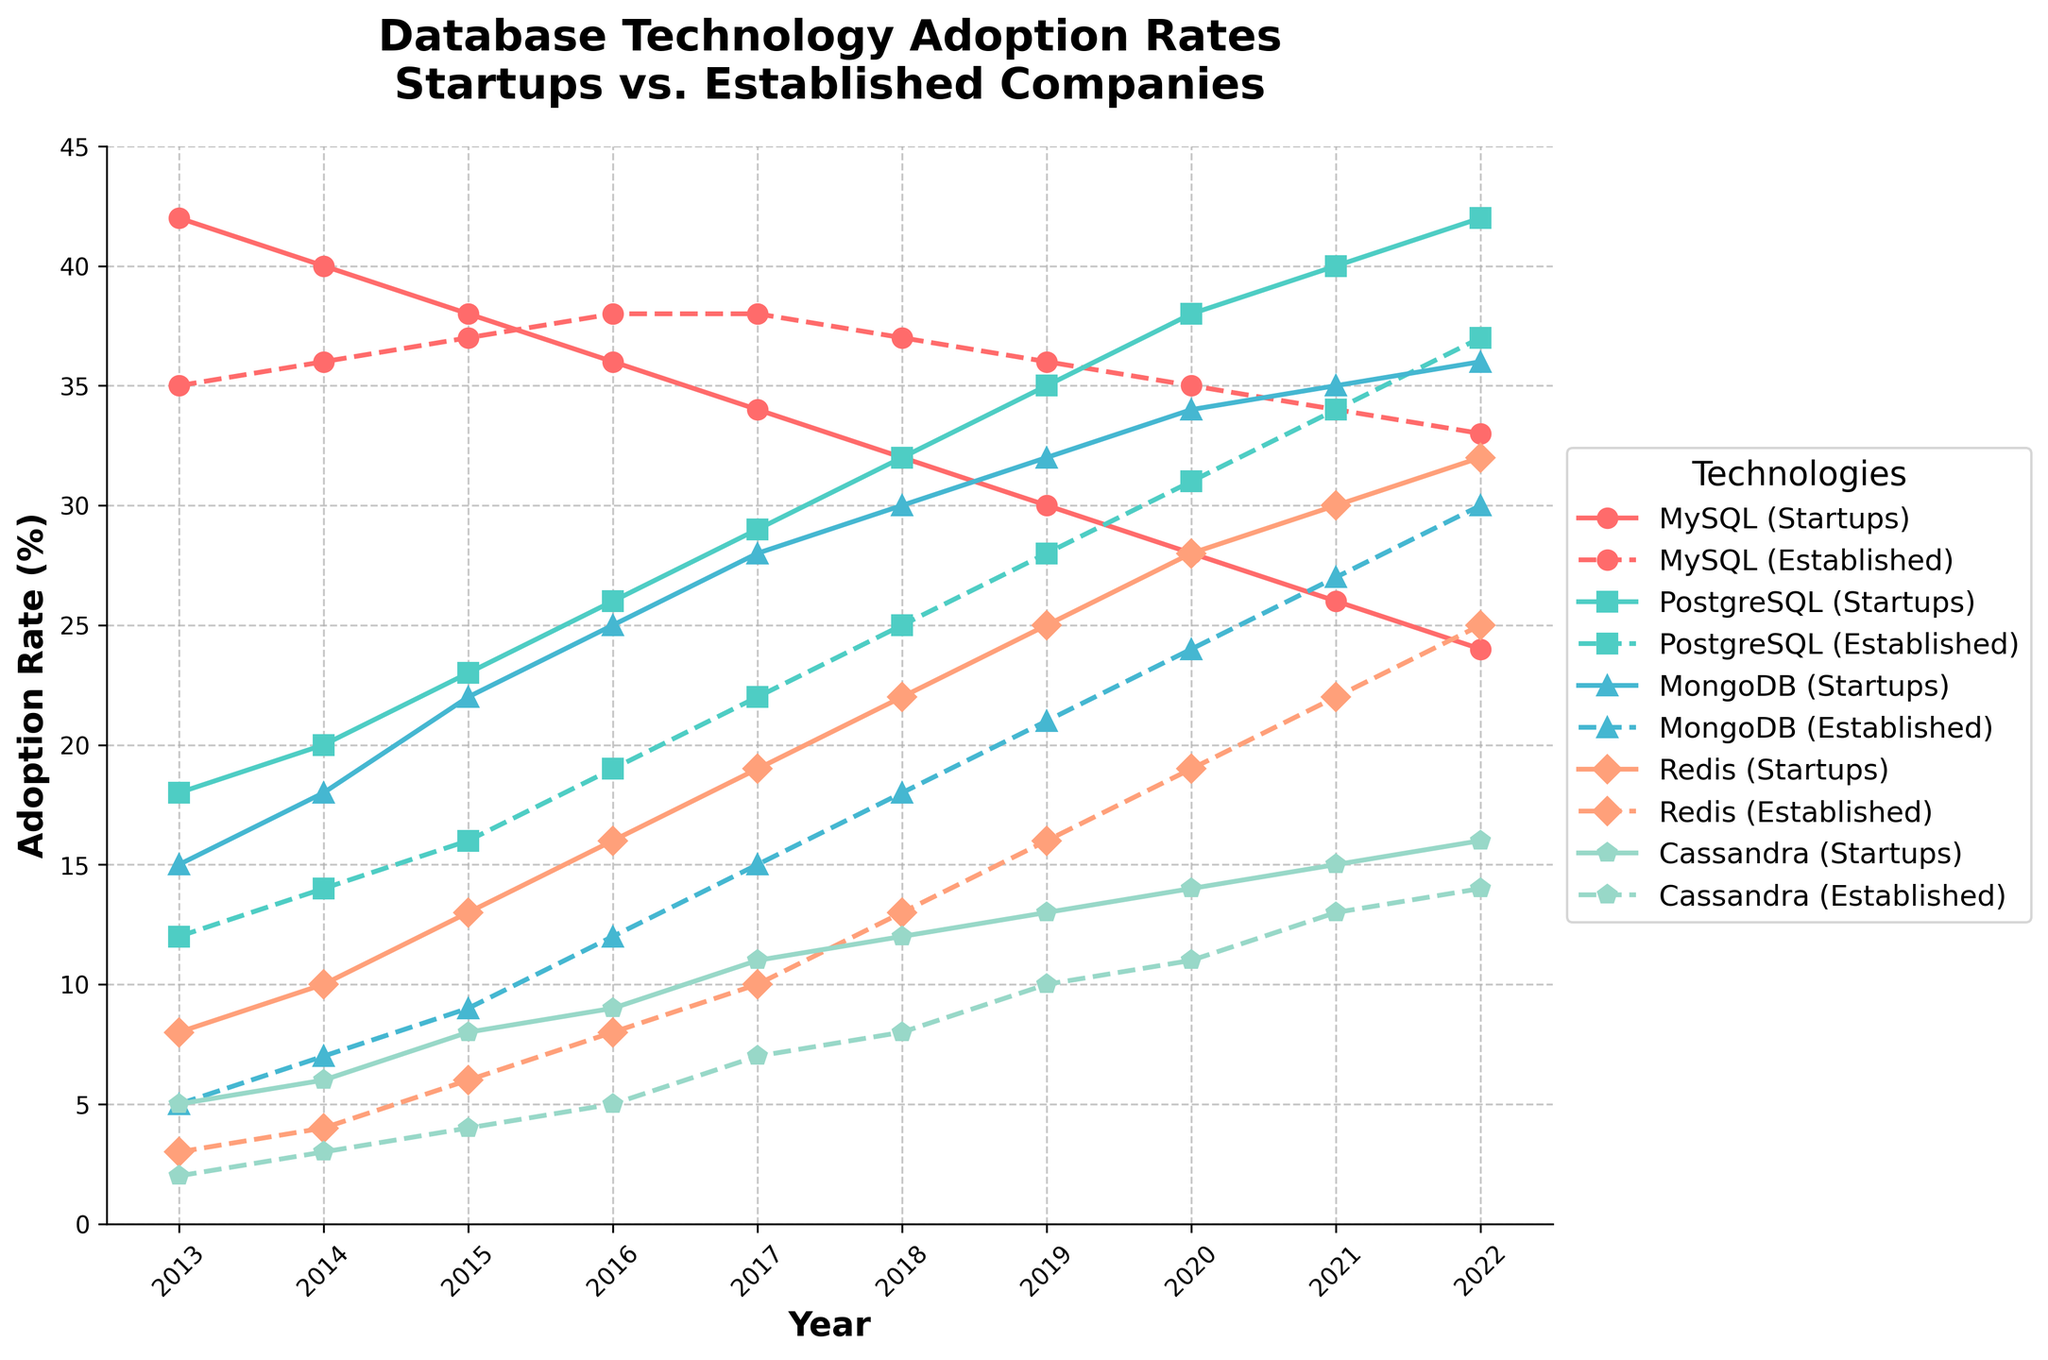What's the trend in MySQL adoption rates for startups over the past decade? The MySQL adoption rate for startups shows a decreasing trend. It starts at 42% in 2013 and gradually declines to 24% in 2022.
Answer: Decreasing Between PostgreSQL adoption by startups and established companies, which shows a more significant increase over the years? PostgreSQL adoption by startups shows a steeper increase. It goes from 18% in 2013 to 42% in 2022, while established companies’ adoption increases from 12% in 2013 to 37% in 2022.
Answer: Startups In which year do MongoDB adoption rates by startups and established companies intersect or come closest? MongoDB adoption rates for both startups and established companies intersect in 2021, with 35% for startups and 27% for established companies.
Answer: 2021 By how much did Redis adoption among established companies increase from 2013 to 2022? Redis adoption among established companies increased from 3% in 2013 to 25% in 2022. The increase is 25% - 3% = 22%.
Answer: 22% Which database technology shows the most significant gap in adoption rates between startups and established companies in 2022? In 2022, MongoDB shows the most significant gap. The adoption rate for startups is 36%, while it is 30% for established companies, resulting in a gap of 6%.
Answer: MongoDB What is the average adoption rate of Cassandra by startups over the depicted years? The adoption rates for Cassandra by startups over the years are 5, 6, 8, 9, 11, 12, 13, 14, 15, and 16. Adding them up gives 109. There are 10 years, so the average is 109/10 = 10.9%.
Answer: 10.9% Which year shows the highest adoption rate of any technology, and what is the rate? In 2022, PostgreSQL adoption by startups is at 42%, which is the highest adoption rate for any technology in any given year.
Answer: 2022, 42% What is the percentage difference in MySQL adoption rates between startups and established companies in 2020? In 2020, MySQL adoption by startups is 28%, while for established companies, it is 35%. The percentage difference is 35% - 28% = 7%.
Answer: 7% How many database technologies show increasing adoption rates for established companies throughout every year (`consistent increase`) from 2013 to 2022? MongoDB and Redis show consistent increases in adoption rates among established companies from 2013 to 2022. MongoDB goes from 5% to 30%, and Redis from 3% to 25%.
Answer: 2 